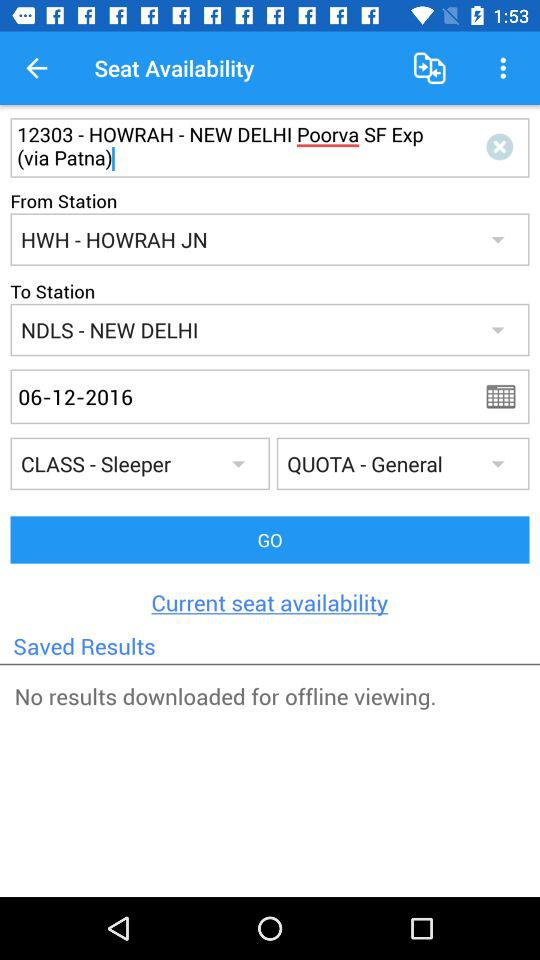What is the express train name? The express train name is "Poorva SF Exp". 